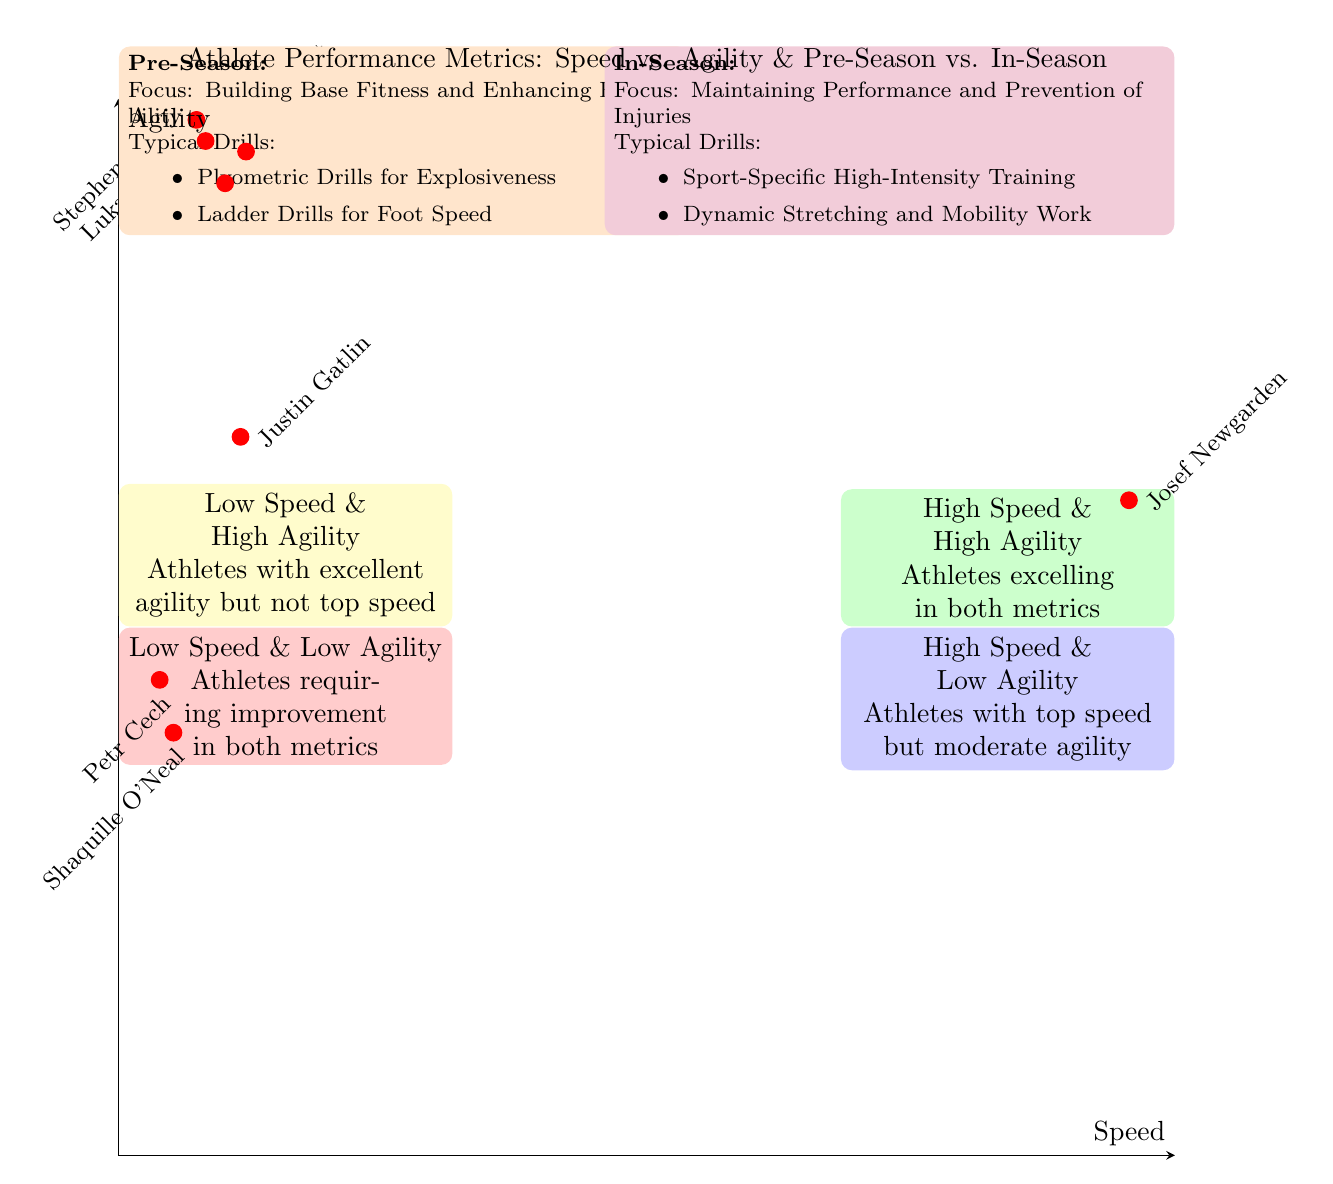What athlete is in the High Speed & High Agility quadrant? In the TopRight quadrant labeled "High Speed & High Agility," the athletes listed are Usain Bolt and Tyreek Hill.
Answer: Usain Bolt What is the Speed Metric of Stephen Curry? In the TopLeft quadrant, Stephen Curry has a Speed Metric of 17.
Answer: 17 Which quadrant contains athletes with excellent agility but not top speed? The TopLeft quadrant is labeled "Low Speed & High Agility," where athletes excel in agility but not speed.
Answer: Low Speed & High Agility What is the Agility Metric of Josef Newgarden? In the BottomRight quadrant, Josef Newgarden has an Agility Metric of 62.
Answer: 62 How many athletes are in the Low Speed & Low Agility quadrant? In the BottomLeft quadrant labeled "Low Speed & Low Agility," there are two athletes listed: Petr Cech and Shaquille O'Neal.
Answer: 2 Which athlete has the highest speed among those listed? Looking at the Speed Metrics, Josef Newgarden has the highest speed at 220.
Answer: 220 What is the focus during the In-Season training? The In-Season focus is on "Maintaining Performance and Prevention of Injuries."
Answer: Maintaining Performance and Prevention of Injuries Which drills are typical in the Pre-Season? The Pre-Season mentions drills like "Plyometric Drills for Explosiveness" and "Ladder Drills for Foot Speed."
Answer: Plyometric Drills for Explosiveness, Ladder Drills for Foot Speed What does the BottomLeft quadrant represent? The BottomLeft quadrant is labeled "Low Speed & Low Agility," indicating athletes who require improvement in both metrics.
Answer: Athletes requiring improvement in both metrics 